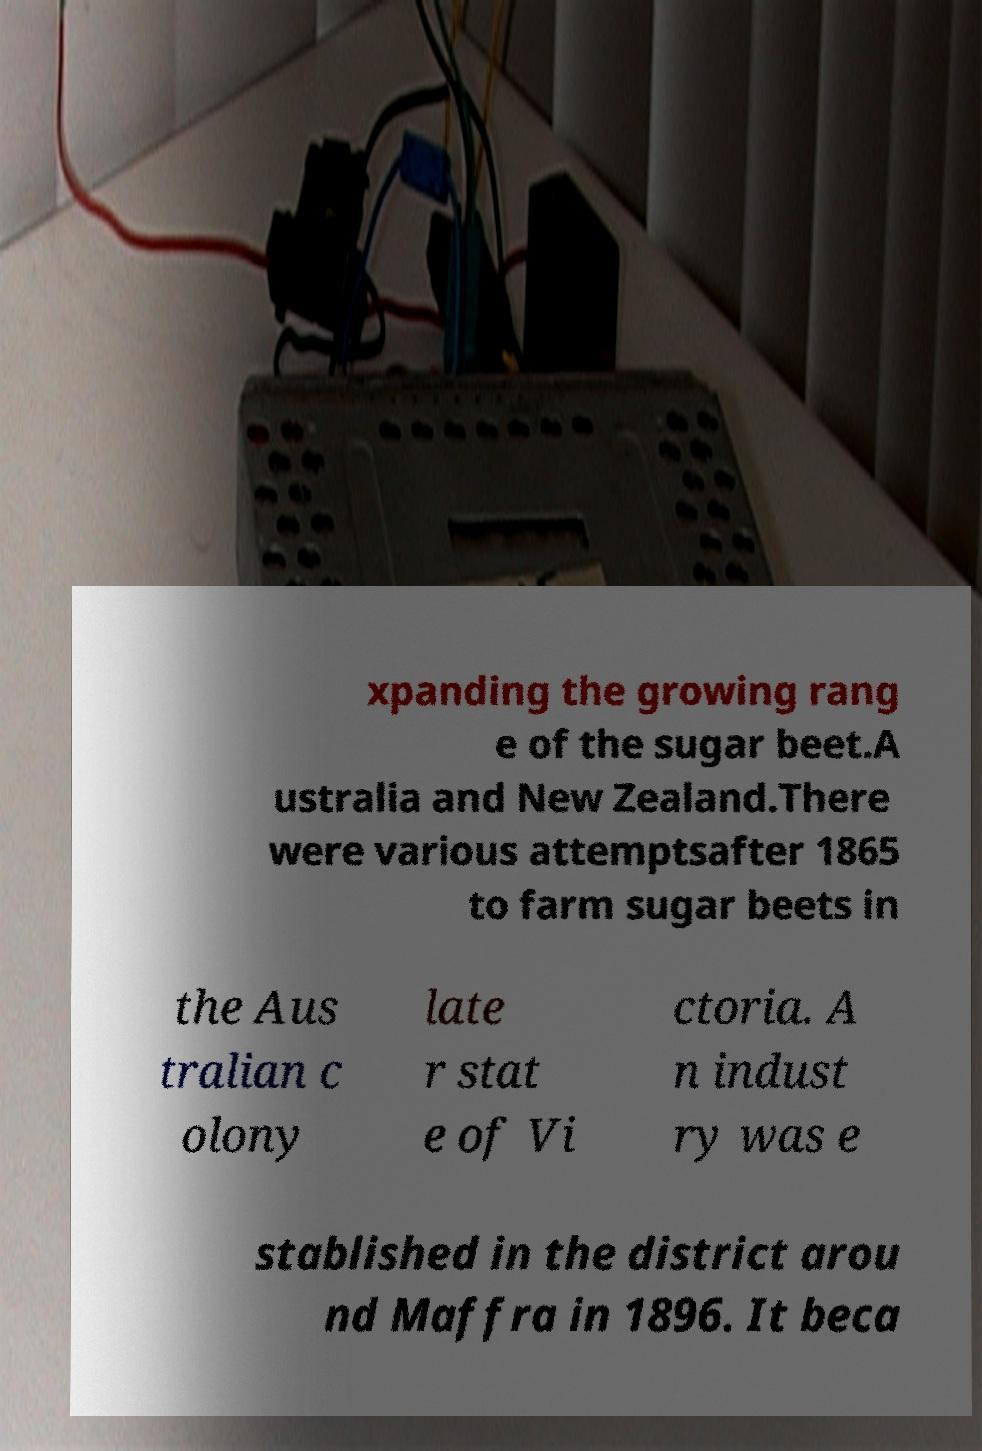Could you assist in decoding the text presented in this image and type it out clearly? xpanding the growing rang e of the sugar beet.A ustralia and New Zealand.There were various attemptsafter 1865 to farm sugar beets in the Aus tralian c olony late r stat e of Vi ctoria. A n indust ry was e stablished in the district arou nd Maffra in 1896. It beca 